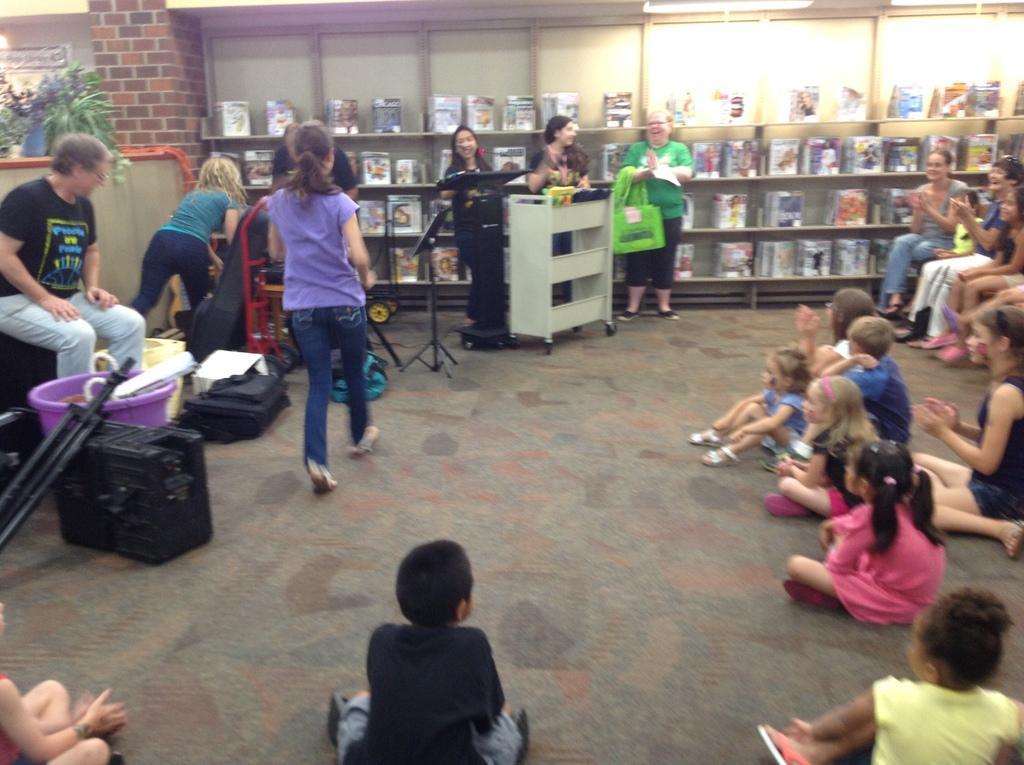Can you describe this image briefly? On the right side of the image we can see a few people are sitting on the chairs and few people are sitting on the floor. On the left side of the image, we can see one person sitting and few people are standing. And we can see stands, bags, one table, one bucket, one wheelchair and a few other objects. In the background there is a wall, plants, racks, books etc. 